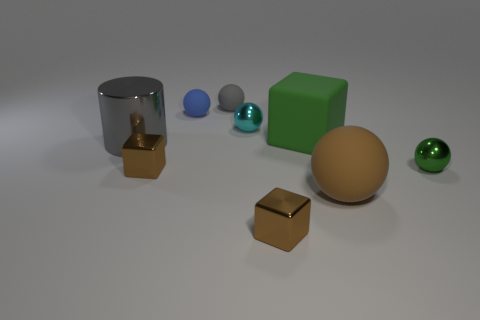There is a matte thing that is both in front of the cyan thing and behind the large metal object; what is its shape?
Offer a very short reply. Cube. How many other objects are there of the same shape as the cyan shiny object?
Ensure brevity in your answer.  4. What is the size of the blue rubber sphere?
Your answer should be very brief. Small. What number of objects are either large gray shiny cylinders or blue spheres?
Offer a terse response. 2. What size is the metallic cube that is on the left side of the small cyan object?
Your answer should be very brief. Small. Are there any other things that have the same size as the cyan ball?
Keep it short and to the point. Yes. What color is the matte object that is both to the right of the tiny gray rubber ball and to the left of the brown sphere?
Keep it short and to the point. Green. Is the ball behind the blue matte thing made of the same material as the cyan thing?
Your answer should be very brief. No. There is a large matte cube; is its color the same as the small ball in front of the metallic cylinder?
Ensure brevity in your answer.  Yes. There is a big brown rubber sphere; are there any big green rubber cubes on the right side of it?
Keep it short and to the point. No. 